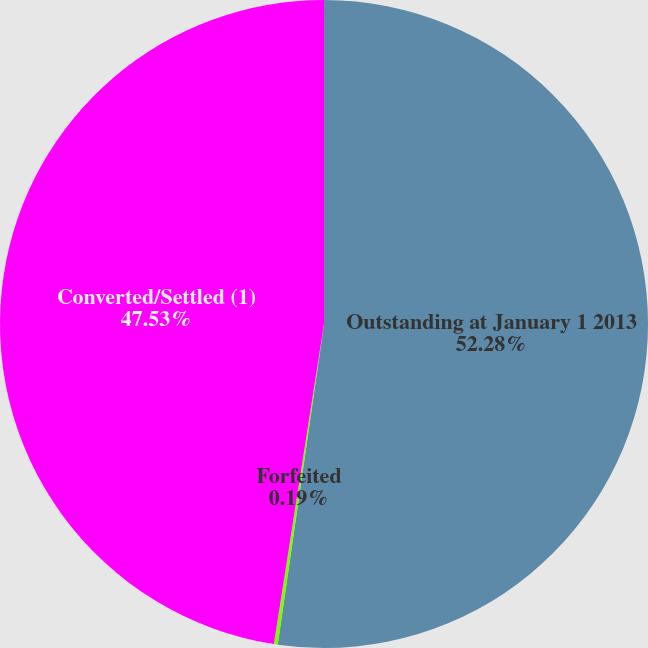<chart> <loc_0><loc_0><loc_500><loc_500><pie_chart><fcel>Outstanding at January 1 2013<fcel>Forfeited<fcel>Converted/Settled (1)<nl><fcel>52.28%<fcel>0.19%<fcel>47.53%<nl></chart> 